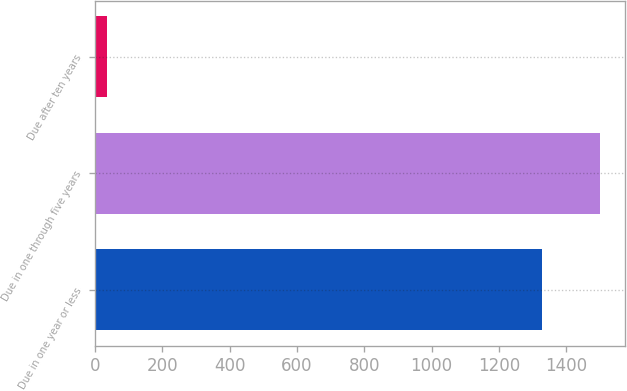Convert chart. <chart><loc_0><loc_0><loc_500><loc_500><bar_chart><fcel>Due in one year or less<fcel>Due in one through five years<fcel>Due after ten years<nl><fcel>1328.4<fcel>1500.9<fcel>36<nl></chart> 